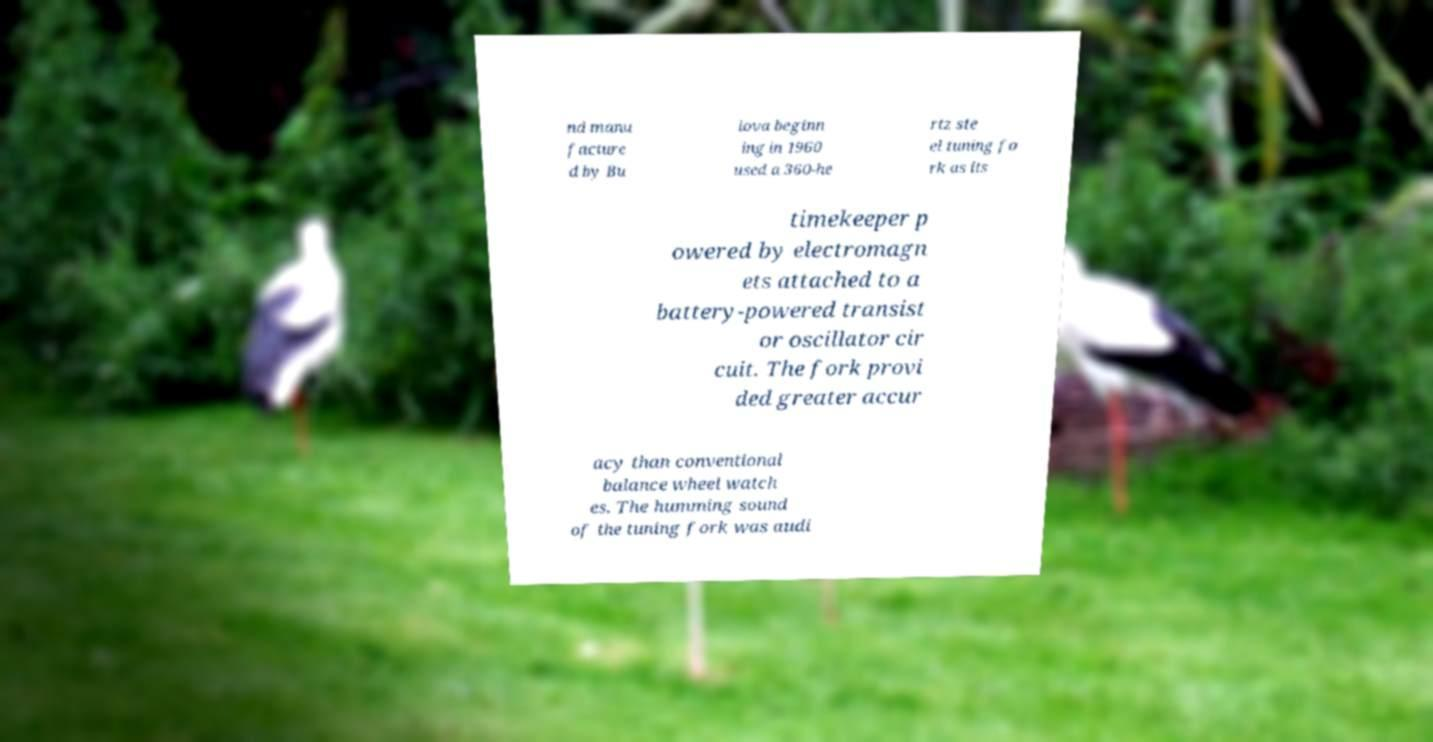I need the written content from this picture converted into text. Can you do that? nd manu facture d by Bu lova beginn ing in 1960 used a 360-he rtz ste el tuning fo rk as its timekeeper p owered by electromagn ets attached to a battery-powered transist or oscillator cir cuit. The fork provi ded greater accur acy than conventional balance wheel watch es. The humming sound of the tuning fork was audi 